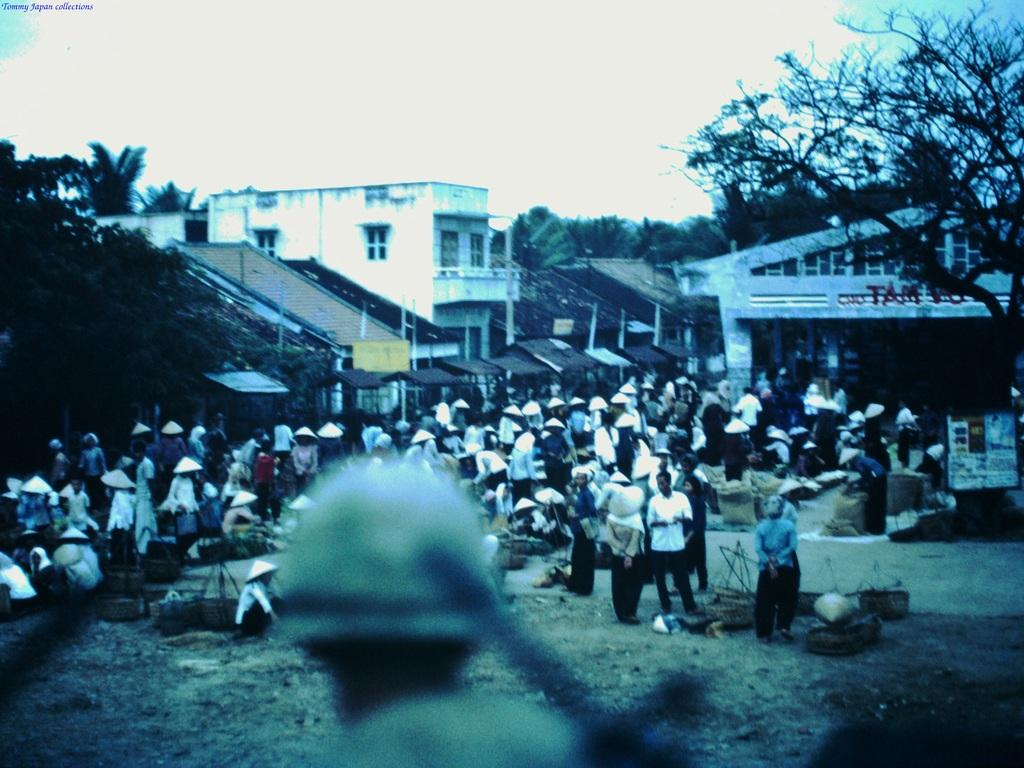What type of structures can be seen in the image? There are houses in the image. Who or what else is present in the image? There are people in the image. What is the surface on which the houses and people are situated? There is ground visible in the image. Are there any objects on the ground? Yes, there are objects on the ground. What other natural elements can be seen in the image? There are trees in the image. Are there any man-made structures or objects besides the houses? Yes, there are poles and boards in the image. What is visible in the background of the image? The sky is visible in the image. Can you see any fish swimming in the sky in the image? No, there are no fish visible in the image, and the sky is not depicted as a body of water. 